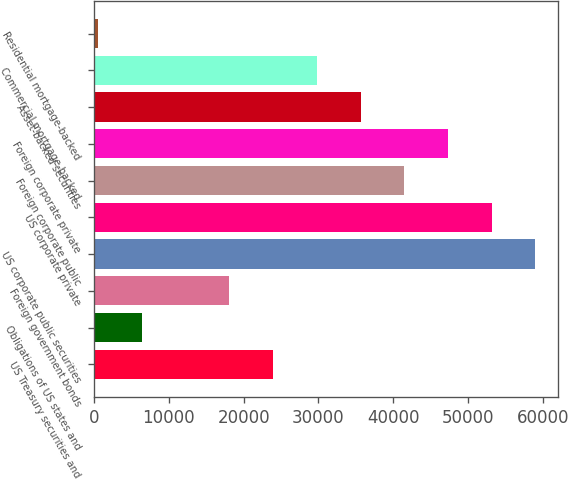Convert chart. <chart><loc_0><loc_0><loc_500><loc_500><bar_chart><fcel>US Treasury securities and<fcel>Obligations of US states and<fcel>Foreign government bonds<fcel>US corporate public securities<fcel>US corporate private<fcel>Foreign corporate public<fcel>Foreign corporate private<fcel>Asset-backed securities<fcel>Commercial mortgage-backed<fcel>Residential mortgage-backed<nl><fcel>23932.4<fcel>6401.6<fcel>18088.8<fcel>58994<fcel>53150.4<fcel>41463.2<fcel>47306.8<fcel>35619.6<fcel>29776<fcel>558<nl></chart> 